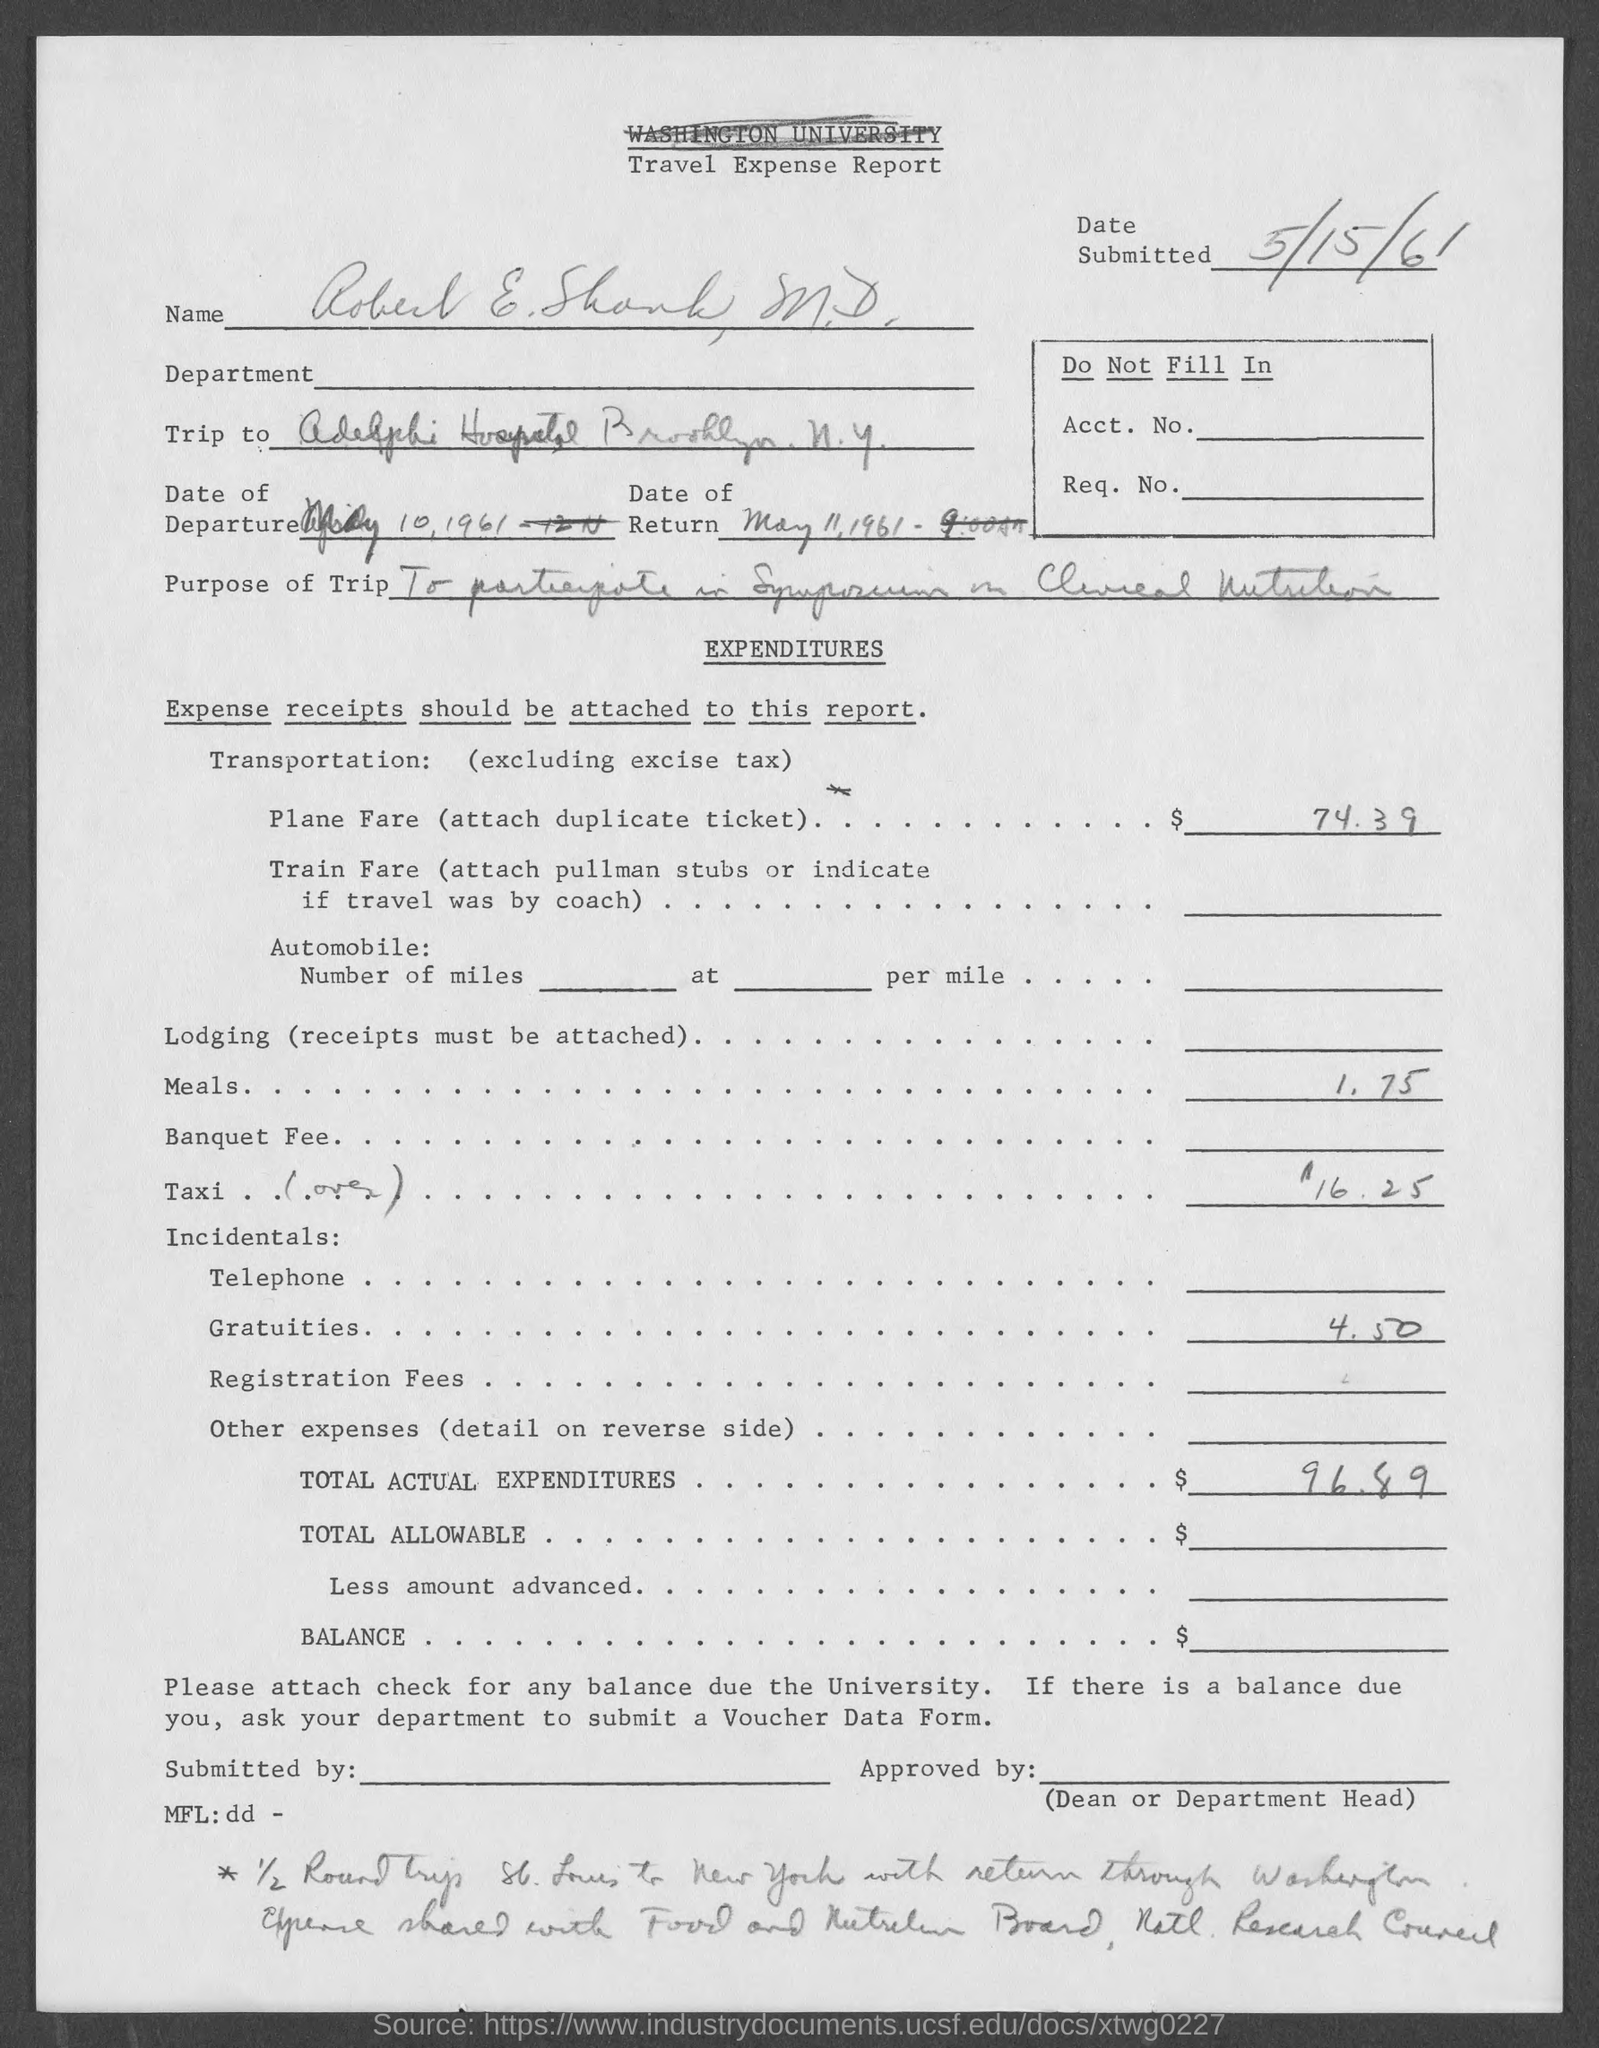List a handful of essential elements in this visual. The name of the report is the Travel Expense Report. 